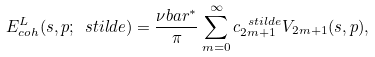<formula> <loc_0><loc_0><loc_500><loc_500>E _ { c o h } ^ { L } ( s , p ; \ s t i l d e ) = \frac { \nu b a r ^ { * } } { \pi } \sum _ { m = 0 } ^ { \infty } c _ { 2 m + 1 } ^ { \ s t i l d e } V _ { 2 m + 1 } ( s , p ) ,</formula> 